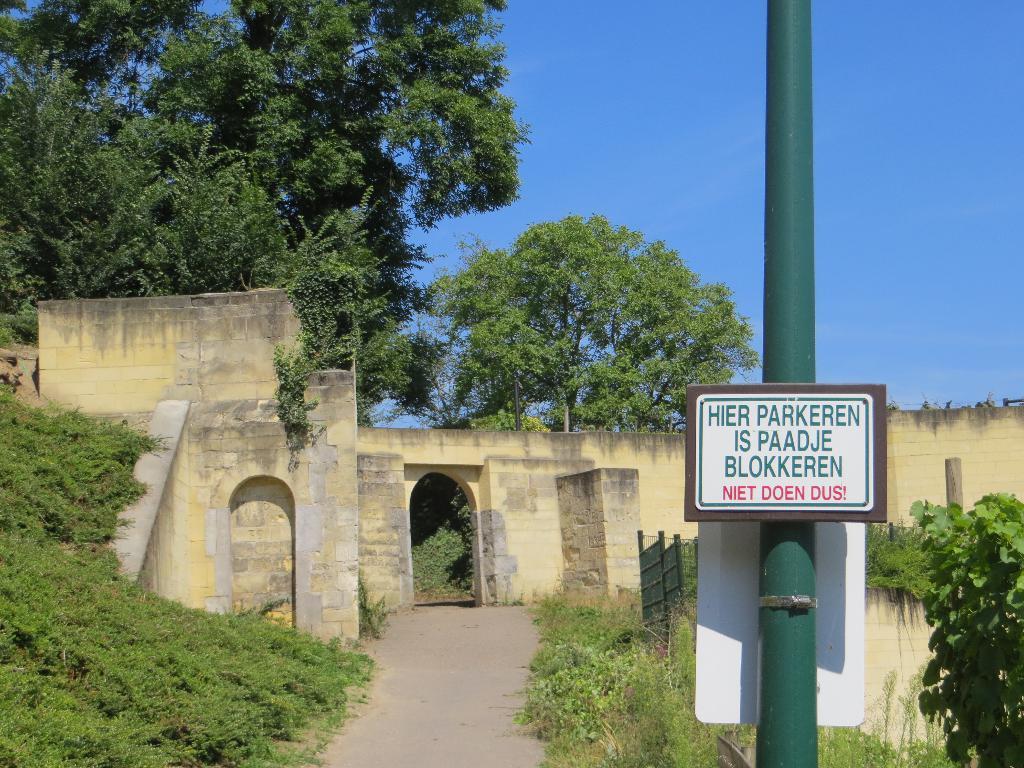Please provide a concise description of this image. In this image we can see a wall, a pole with words, there are few plants, trees and the sky in the background. 